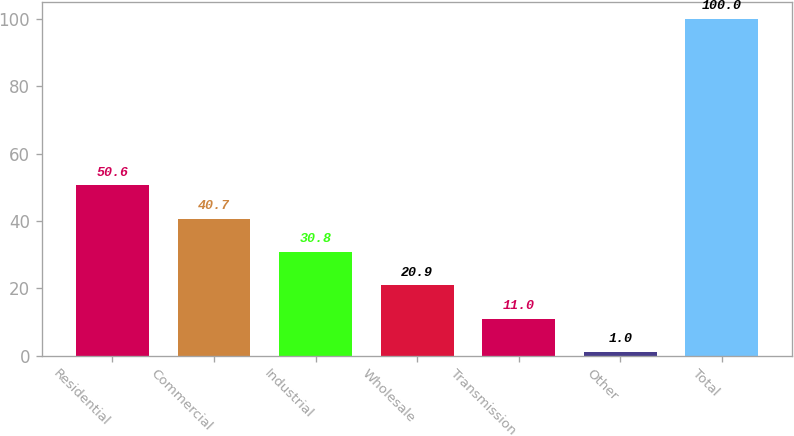Convert chart. <chart><loc_0><loc_0><loc_500><loc_500><bar_chart><fcel>Residential<fcel>Commercial<fcel>Industrial<fcel>Wholesale<fcel>Transmission<fcel>Other<fcel>Total<nl><fcel>50.6<fcel>40.7<fcel>30.8<fcel>20.9<fcel>11<fcel>1<fcel>100<nl></chart> 